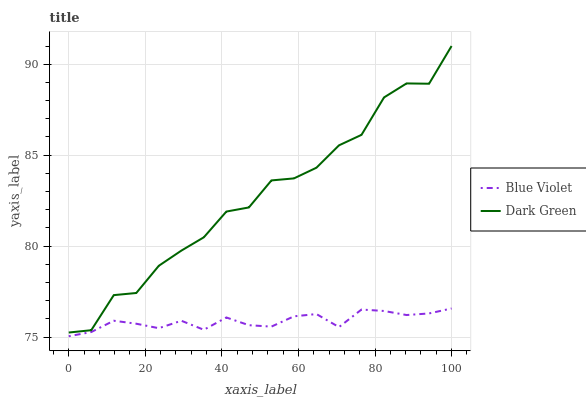Does Blue Violet have the minimum area under the curve?
Answer yes or no. Yes. Does Dark Green have the maximum area under the curve?
Answer yes or no. Yes. Does Dark Green have the minimum area under the curve?
Answer yes or no. No. Is Blue Violet the smoothest?
Answer yes or no. Yes. Is Dark Green the roughest?
Answer yes or no. Yes. Is Dark Green the smoothest?
Answer yes or no. No. Does Blue Violet have the lowest value?
Answer yes or no. Yes. Does Dark Green have the lowest value?
Answer yes or no. No. Does Dark Green have the highest value?
Answer yes or no. Yes. Is Blue Violet less than Dark Green?
Answer yes or no. Yes. Is Dark Green greater than Blue Violet?
Answer yes or no. Yes. Does Blue Violet intersect Dark Green?
Answer yes or no. No. 